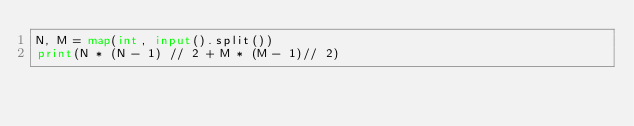Convert code to text. <code><loc_0><loc_0><loc_500><loc_500><_Python_>N, M = map(int, input().split())
print(N * (N - 1) // 2 + M * (M - 1)// 2)</code> 